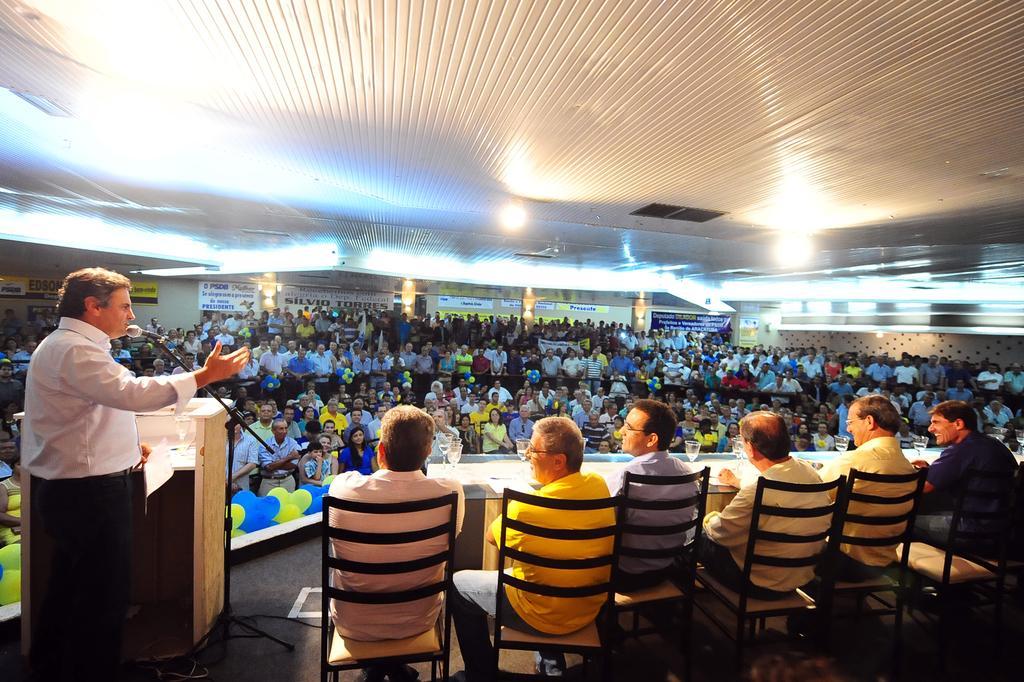Can you describe this image briefly? In this picture we can see a conference hall and here is the table and glass on it, and group of people sitting on a chair, and here is person standing and speaking, and here is the microphone, and there are group of persons sitting in front and some are standing and here is the light. 